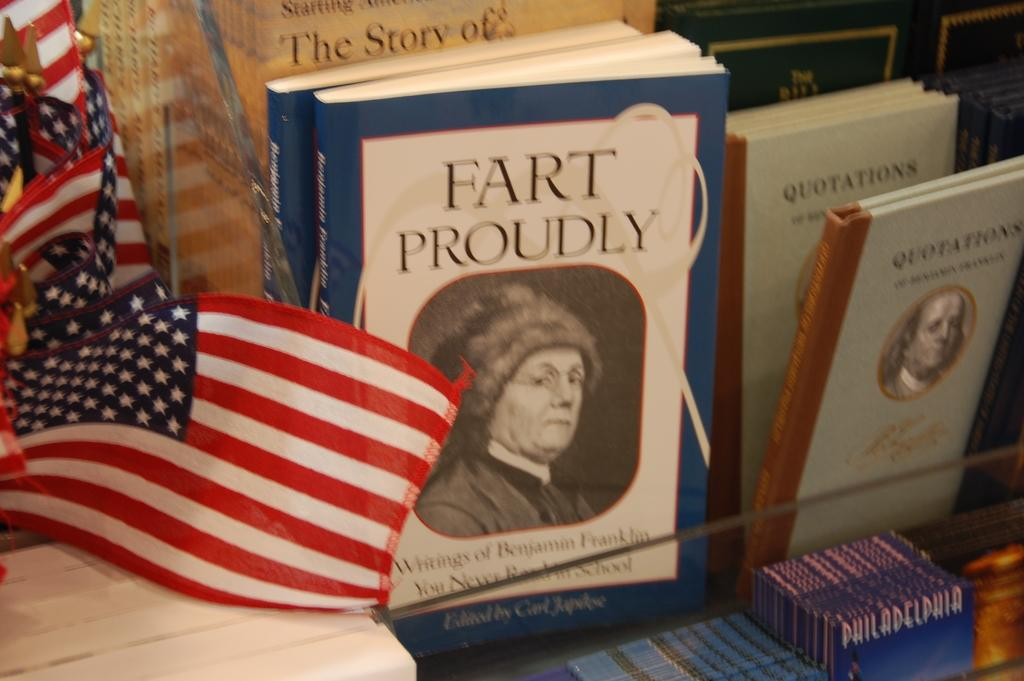<image>
Share a concise interpretation of the image provided. Benjamin Franklin wrote a book called "Fart Proudly." 